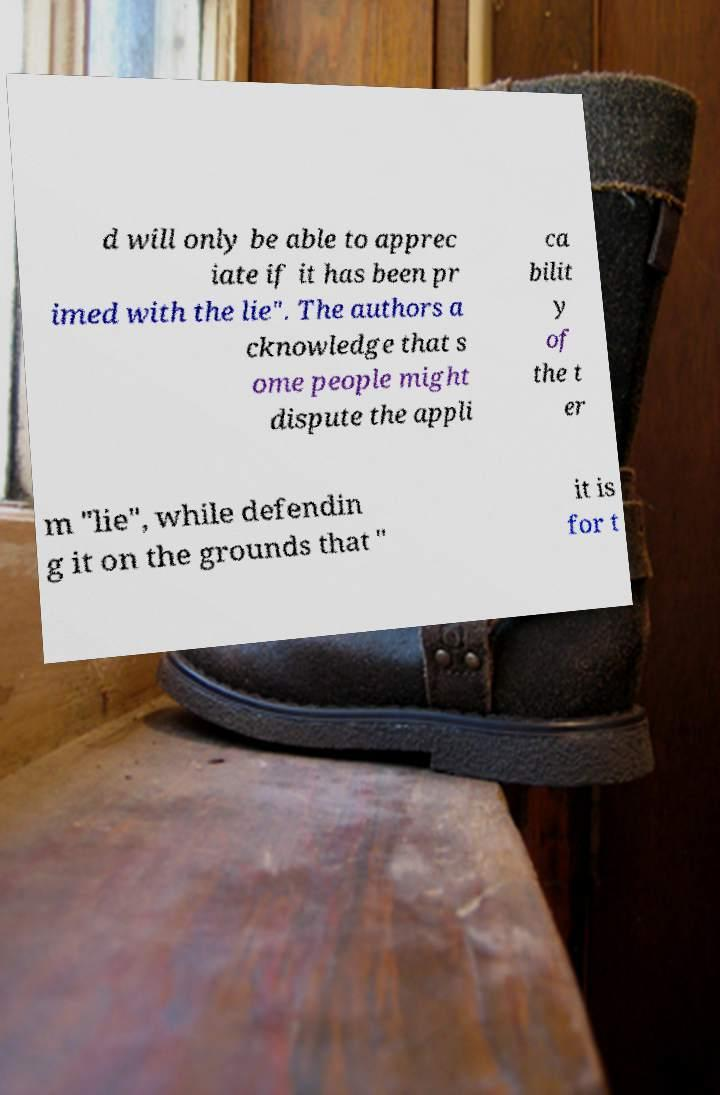I need the written content from this picture converted into text. Can you do that? d will only be able to apprec iate if it has been pr imed with the lie". The authors a cknowledge that s ome people might dispute the appli ca bilit y of the t er m "lie", while defendin g it on the grounds that " it is for t 